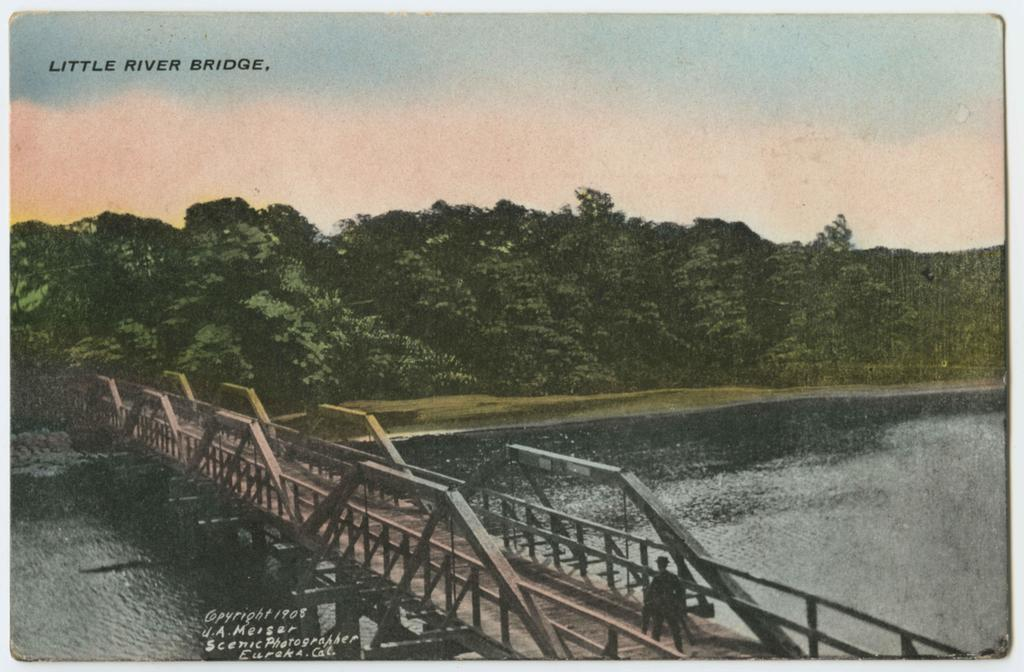What is present in the image that contains visual and written information? There is a poster in the image that contains images and text. Can you describe the content of the poster? The poster contains images and text, but the specific content cannot be determined from the provided facts. What religion is depicted in the poster? There is no information about religion in the image, as it only contains a poster with images and text. 